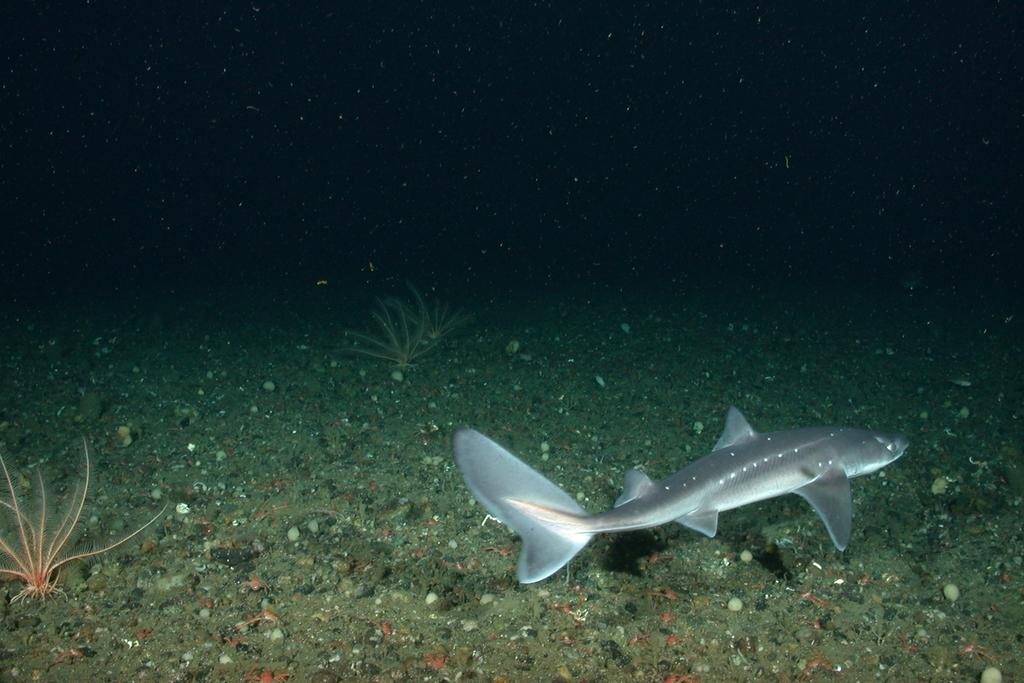What type of environment is shown in the image? The image depicts an underwater environment. What can be seen growing in the underwater environment? There are plants visible in the image. What type of animal can be seen in the underwater environment? There is a fish in the image. What type of sheet is covering the sand in the image? There is no sheet or sand present in the image; it depicts an underwater environment with plants and a fish. 